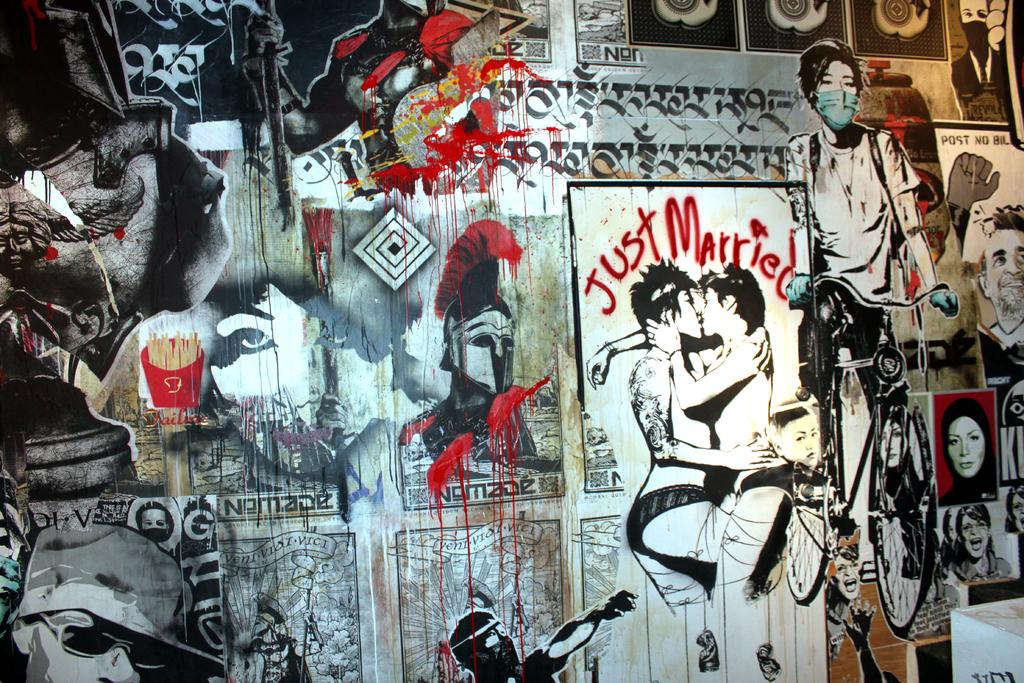What type of wall is visible in the image? There is a wooden wall in the image. What is displayed on the wooden wall? There is an art piece on the wall. What does the art piece depict? The art piece depicts persons and a cycle. Are there any other objects or elements in the art piece? Yes, the art piece includes other objects. How many balls are included in the art piece? There are no balls present in the image or the art piece. 